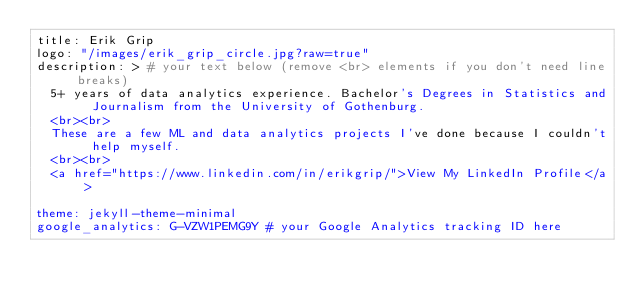<code> <loc_0><loc_0><loc_500><loc_500><_YAML_>title: Erik Grip
logo: "/images/erik_grip_circle.jpg?raw=true"
description: > # your text below (remove <br> elements if you don't need line breaks)
  5+ years of data analytics experience. Bachelor's Degrees in Statistics and Journalism from the University of Gothenburg.
  <br><br>
  These are a few ML and data analytics projects I've done because I couldn't help myself.
  <br><br>
  <a href="https://www.linkedin.com/in/erikgrip/">View My LinkedIn Profile</a>

theme: jekyll-theme-minimal
google_analytics: G-VZW1PEMG9Y # your Google Analytics tracking ID here
</code> 